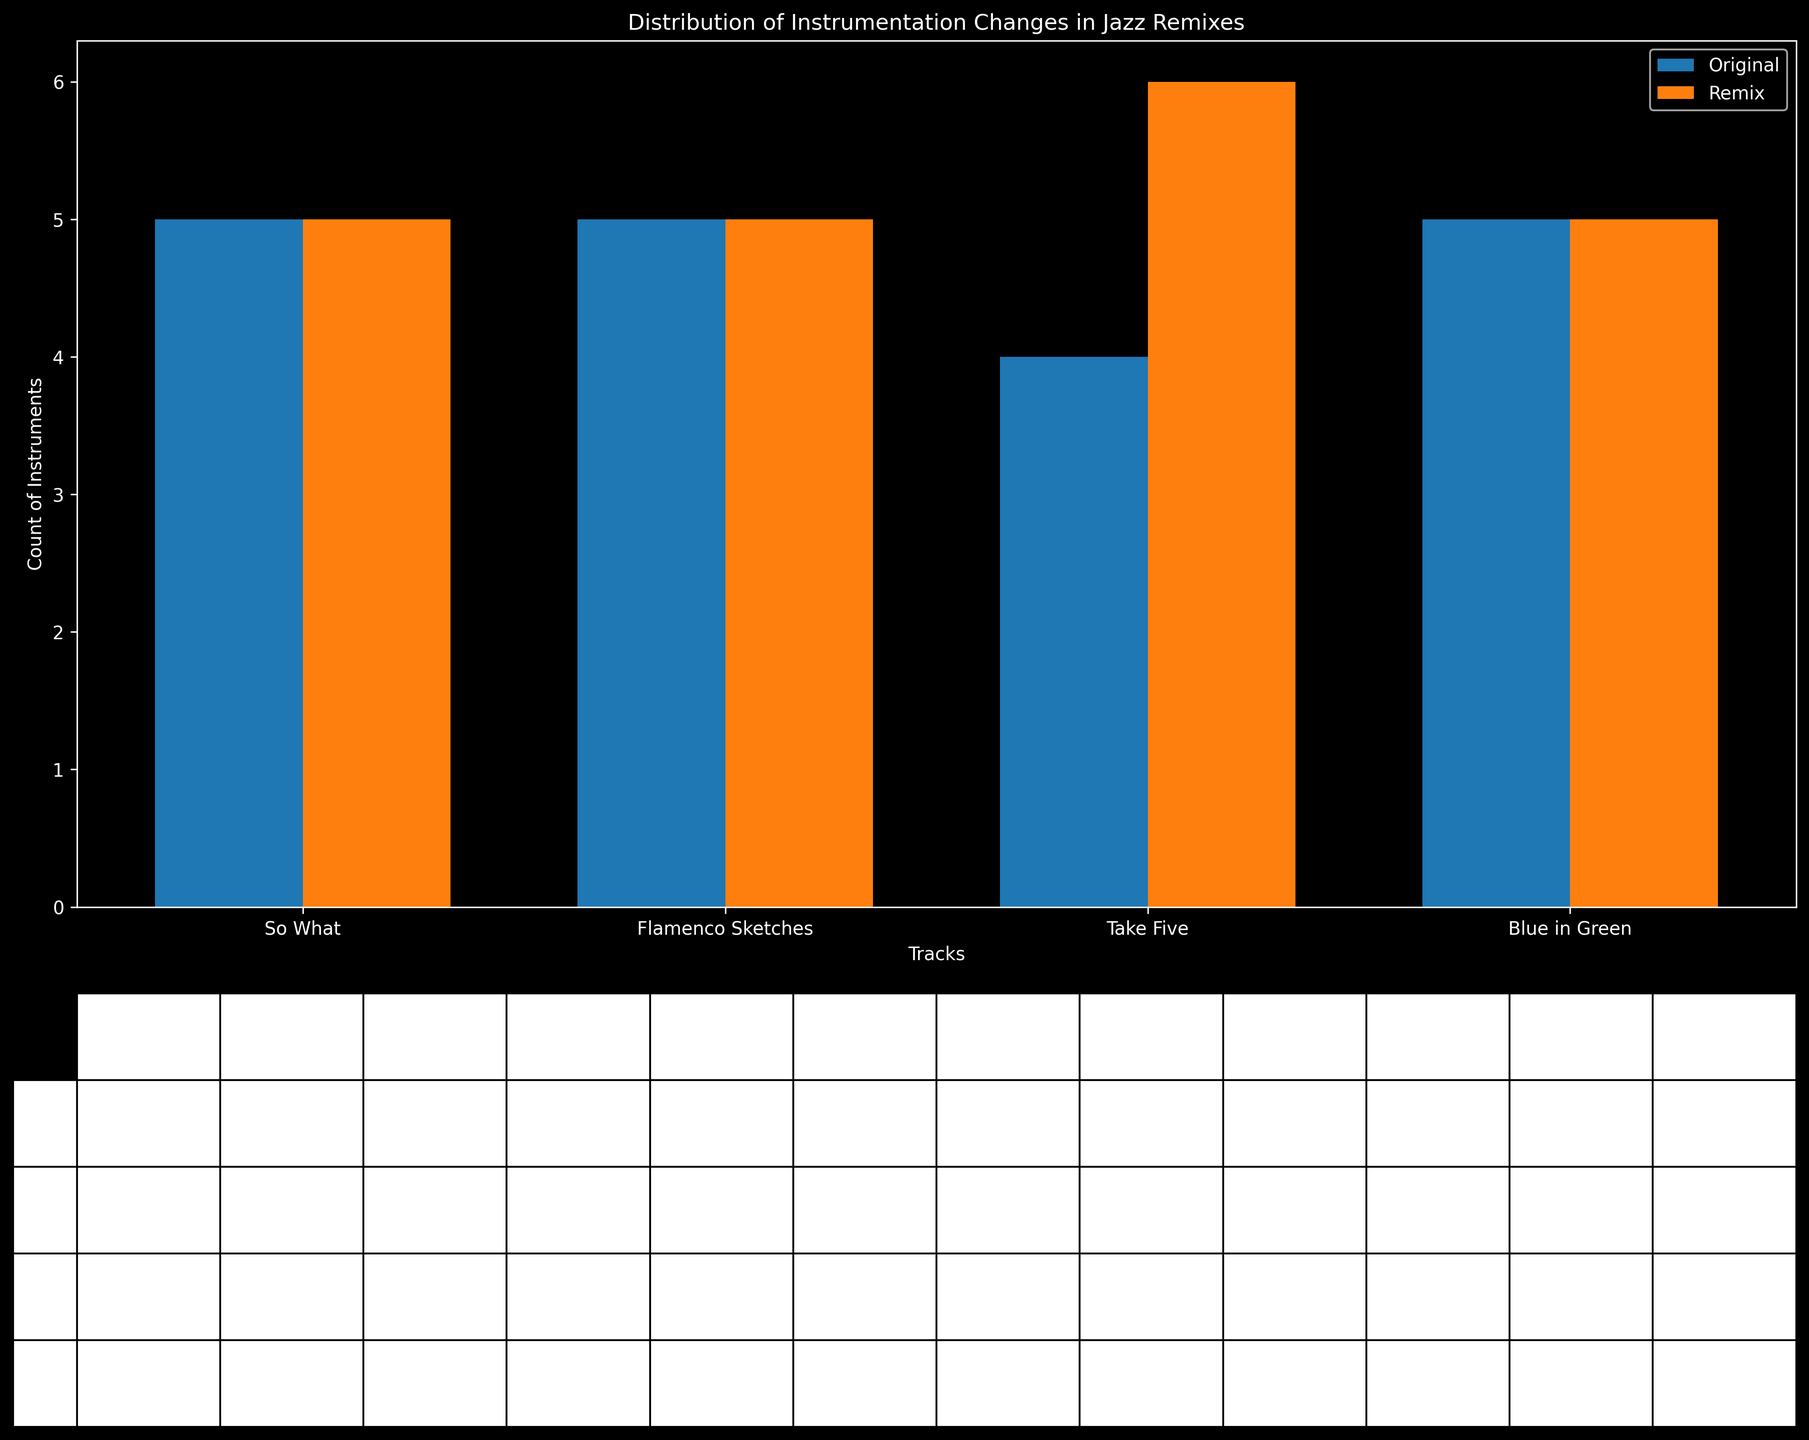What instrument is added in the remix of "So What" that wasn't in the original? In the table, for the track "So What," the column "Electronic Elements (Remix)" shows 1 while "Electronic Elements (Original)" shows 0, indicating that Electronic Elements were added in the remix.
Answer: Electronic Elements Which track has the greatest number of instrument changes from the original to the remix? By comparing the number of columns that change from 1 to 0 or from 0 to 1 in the Remix columns across all tracks, "Blue in Green" and "So What" both have one more instrument change than others where Drums were removed and Electronic Elements were added.
Answer: Blue in Green and So What How many instruments does "Take Five" have in its original version that are also present in the remix? By looking at "Take Five" row, count the instruments where both "Original" and "Remix" columns show 1. The instruments are Saxophone, Piano, Bass, and Drums.
Answer: 4 How does the number of instruments in the original version of "Take Five" compare to the remix version of "Blue in Green"? Check the number of 1s in "Take Five (Original)" and "Blue in Green (Remix)." "Take Five (Original)" shows Trumpet (0), Saxophone (1), Piano (1), Bass (1), Drums (1), Electronic Elements (0), totaling 4. "Blue in Green (Remix)" shows Trumpet (1), Saxophone (1), Piano (1), Bass (1), Drums (0), Electronic Elements (1), totaling 5. "Blue in Green (Remix)" has 1 more instrument.
Answer: Larger by 1 in "Blue in Green (Remix)" What is the average number of instruments in the remixes across all tracks? Add up the total number of instruments in all remixes and divide by the number of tracks. So What: 5, Flamenco Sketches: 5, Take Five: 4, Blue in Green: 5. Total = 5+5+4+5 = 19, Average = 19/4 = 4.75.
Answer: 4.75 Which instrument is omitted in the remix of "Flamenco Sketches" that was present in the original? Checking the row for "Flamenco Sketches," "Drums (Remix)" shows 0 while "Drums (Original)" shows 1. Hence, Drums are omitted in the remix.
Answer: Drums Which pair of tracks have exactly the same number of instruments in both their original and remixed versions? Comparing original and remixed versions instrument counts, "So What" and "Flamenco Sketches" both have 5 instruments in each version (Original and Remix).
Answer: So What and Flamenco Sketches Which track has the highest count of added instruments in its remix version? Identify the columns where instruments are added (0 in original, 1 in remix). "Take Five" has Electronic Elements added in the remix version, making it the only added instrument.
Answer: Take Five 